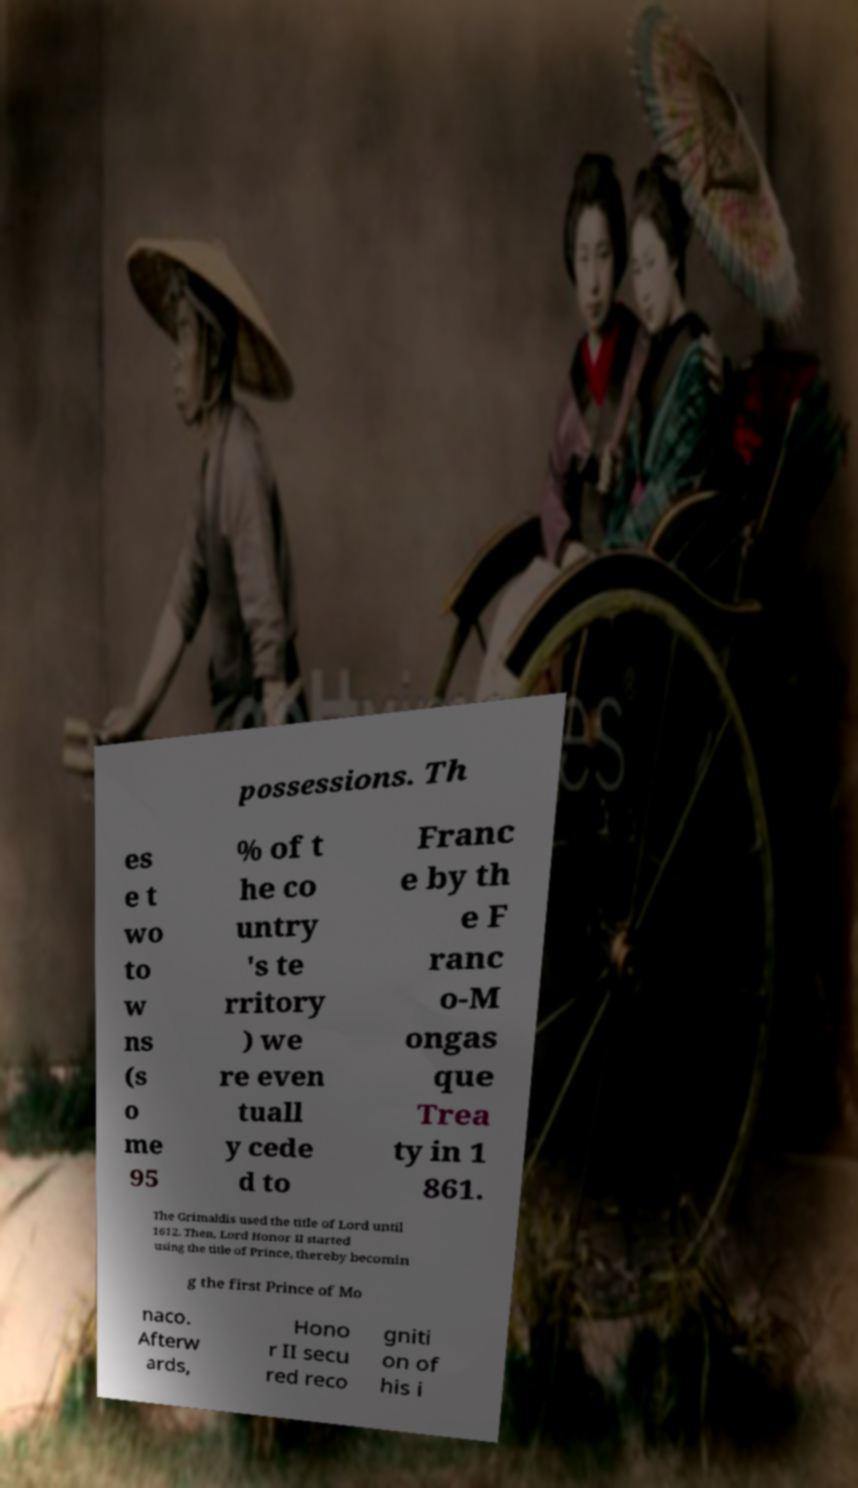Can you accurately transcribe the text from the provided image for me? possessions. Th es e t wo to w ns (s o me 95 % of t he co untry 's te rritory ) we re even tuall y cede d to Franc e by th e F ranc o-M ongas que Trea ty in 1 861. The Grimaldis used the title of Lord until 1612. Then, Lord Honor II started using the title of Prince, thereby becomin g the first Prince of Mo naco. Afterw ards, Hono r II secu red reco gniti on of his i 